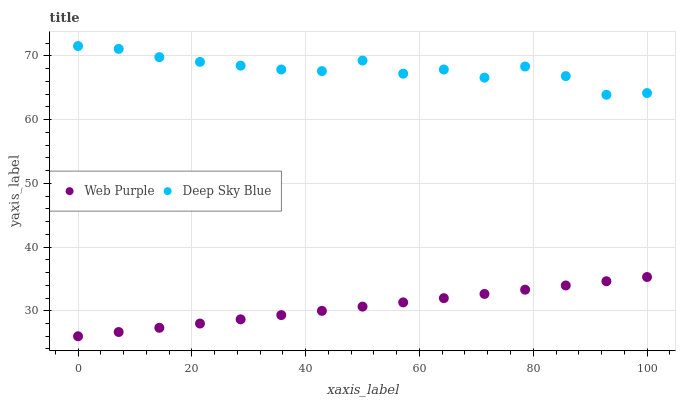Does Web Purple have the minimum area under the curve?
Answer yes or no. Yes. Does Deep Sky Blue have the maximum area under the curve?
Answer yes or no. Yes. Does Deep Sky Blue have the minimum area under the curve?
Answer yes or no. No. Is Web Purple the smoothest?
Answer yes or no. Yes. Is Deep Sky Blue the roughest?
Answer yes or no. Yes. Is Deep Sky Blue the smoothest?
Answer yes or no. No. Does Web Purple have the lowest value?
Answer yes or no. Yes. Does Deep Sky Blue have the lowest value?
Answer yes or no. No. Does Deep Sky Blue have the highest value?
Answer yes or no. Yes. Is Web Purple less than Deep Sky Blue?
Answer yes or no. Yes. Is Deep Sky Blue greater than Web Purple?
Answer yes or no. Yes. Does Web Purple intersect Deep Sky Blue?
Answer yes or no. No. 